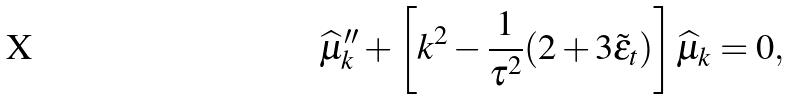<formula> <loc_0><loc_0><loc_500><loc_500>\widehat { \mu } _ { k } ^ { \prime \prime } + \left [ k ^ { 2 } - \frac { 1 } { \tau ^ { 2 } } ( 2 + 3 \tilde { \epsilon } _ { t } ) \right ] \widehat { \mu } _ { k } & = 0 ,</formula> 